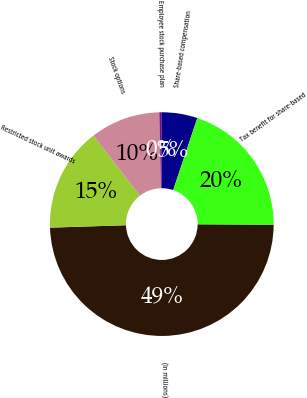Convert chart to OTSL. <chart><loc_0><loc_0><loc_500><loc_500><pie_chart><fcel>(In millions)<fcel>Restricted stock unit awards<fcel>Stock options<fcel>Employee stock purchase plan<fcel>Share-based compensation<fcel>Tax benefit for share-based<nl><fcel>49.41%<fcel>15.03%<fcel>10.12%<fcel>0.29%<fcel>5.21%<fcel>19.94%<nl></chart> 